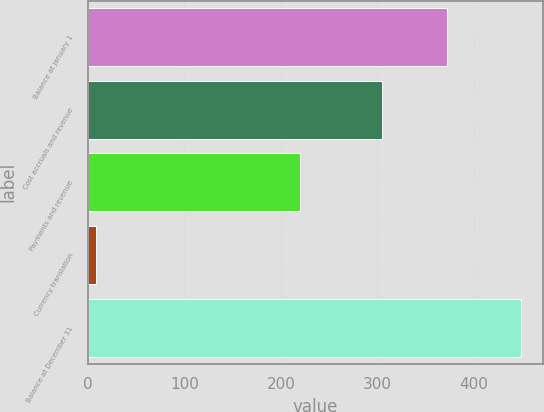<chart> <loc_0><loc_0><loc_500><loc_500><bar_chart><fcel>Balance at January 1<fcel>Cost accruals and revenue<fcel>Payments and revenue<fcel>Currency translation<fcel>Balance at December 31<nl><fcel>372.2<fcel>304.3<fcel>219.6<fcel>8.2<fcel>448.7<nl></chart> 